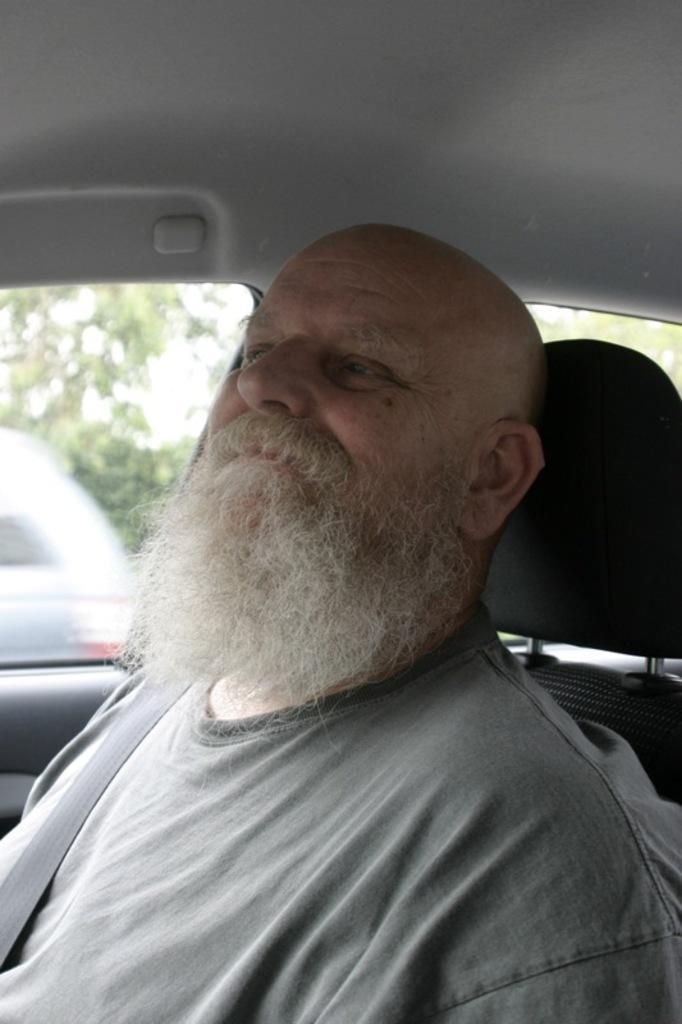Could you give a brief overview of what you see in this image? In a picture there is a person sitting in a car through the glass window we can see vehicles and clear sky. 